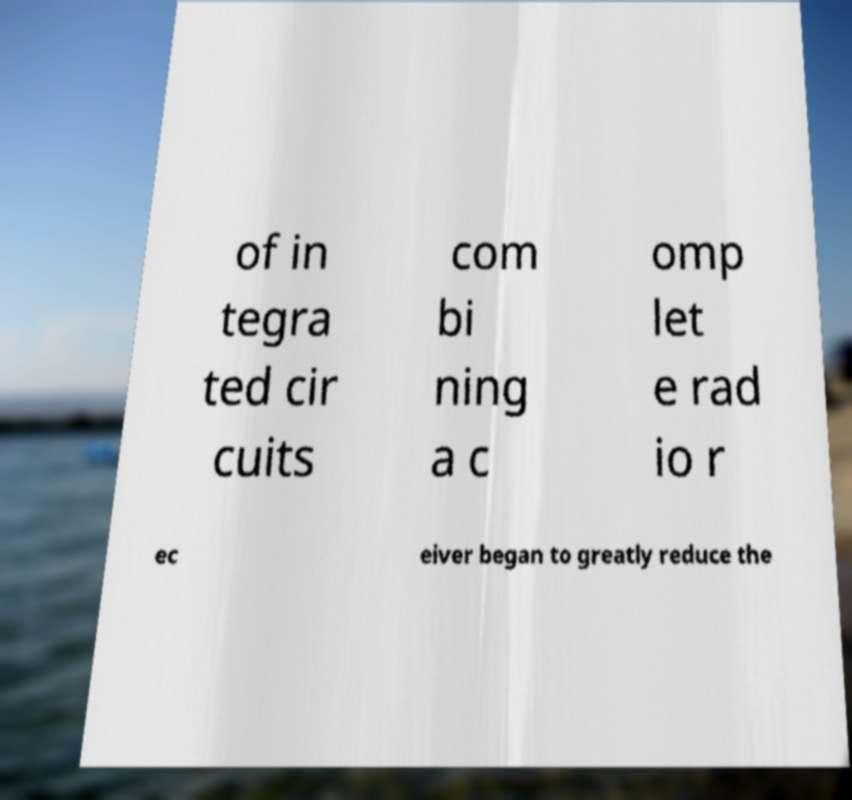Can you accurately transcribe the text from the provided image for me? of in tegra ted cir cuits com bi ning a c omp let e rad io r ec eiver began to greatly reduce the 